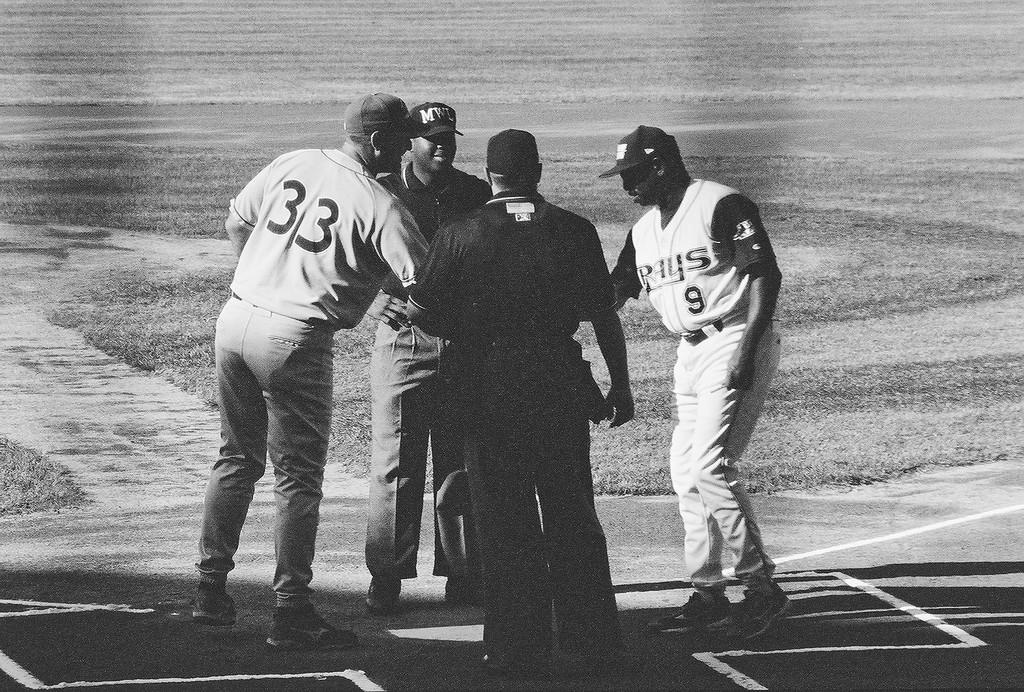<image>
Relay a brief, clear account of the picture shown. Number 33 and number 9 are shaking hands at home plate. 